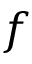<formula> <loc_0><loc_0><loc_500><loc_500>f</formula> 